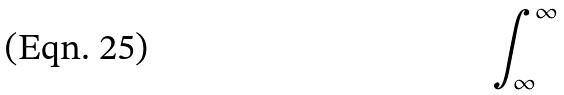Convert formula to latex. <formula><loc_0><loc_0><loc_500><loc_500>\int _ { \infty } ^ { \infty }</formula> 